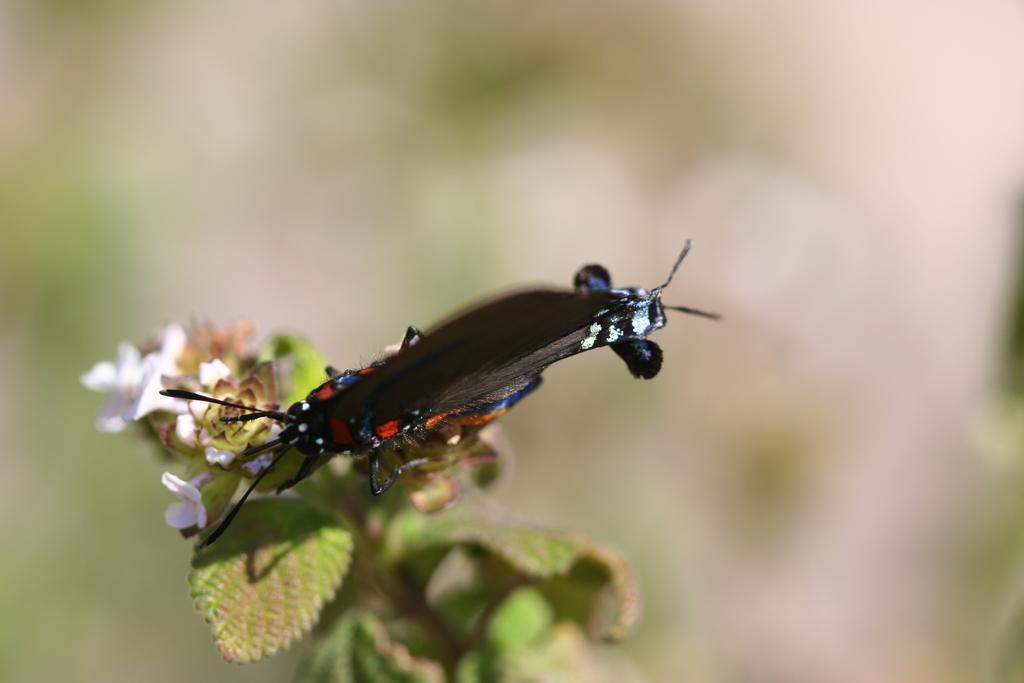In one or two sentences, can you explain what this image depicts? In this image we can see a insect on the plant. 